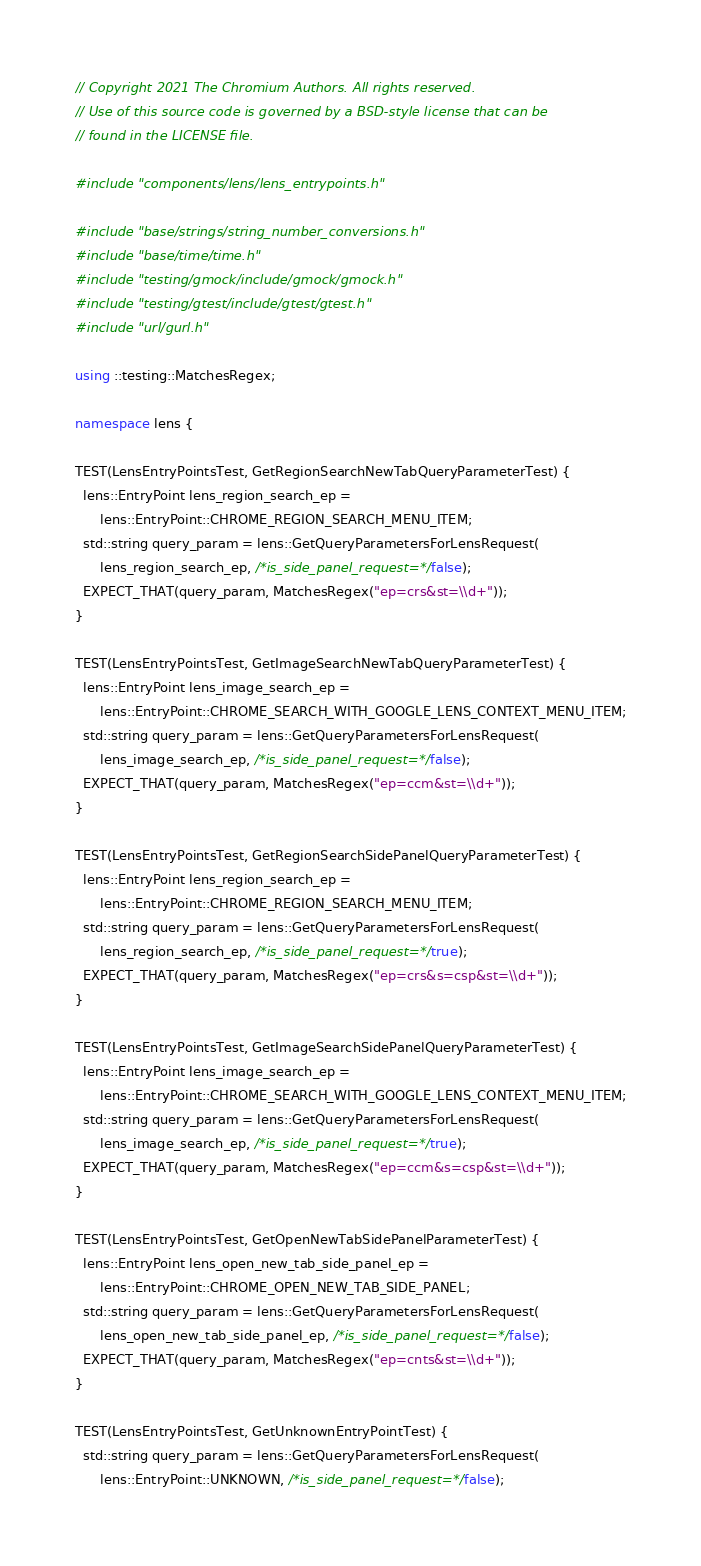Convert code to text. <code><loc_0><loc_0><loc_500><loc_500><_C++_>// Copyright 2021 The Chromium Authors. All rights reserved.
// Use of this source code is governed by a BSD-style license that can be
// found in the LICENSE file.

#include "components/lens/lens_entrypoints.h"

#include "base/strings/string_number_conversions.h"
#include "base/time/time.h"
#include "testing/gmock/include/gmock/gmock.h"
#include "testing/gtest/include/gtest/gtest.h"
#include "url/gurl.h"

using ::testing::MatchesRegex;

namespace lens {

TEST(LensEntryPointsTest, GetRegionSearchNewTabQueryParameterTest) {
  lens::EntryPoint lens_region_search_ep =
      lens::EntryPoint::CHROME_REGION_SEARCH_MENU_ITEM;
  std::string query_param = lens::GetQueryParametersForLensRequest(
      lens_region_search_ep, /*is_side_panel_request=*/false);
  EXPECT_THAT(query_param, MatchesRegex("ep=crs&st=\\d+"));
}

TEST(LensEntryPointsTest, GetImageSearchNewTabQueryParameterTest) {
  lens::EntryPoint lens_image_search_ep =
      lens::EntryPoint::CHROME_SEARCH_WITH_GOOGLE_LENS_CONTEXT_MENU_ITEM;
  std::string query_param = lens::GetQueryParametersForLensRequest(
      lens_image_search_ep, /*is_side_panel_request=*/false);
  EXPECT_THAT(query_param, MatchesRegex("ep=ccm&st=\\d+"));
}

TEST(LensEntryPointsTest, GetRegionSearchSidePanelQueryParameterTest) {
  lens::EntryPoint lens_region_search_ep =
      lens::EntryPoint::CHROME_REGION_SEARCH_MENU_ITEM;
  std::string query_param = lens::GetQueryParametersForLensRequest(
      lens_region_search_ep, /*is_side_panel_request=*/true);
  EXPECT_THAT(query_param, MatchesRegex("ep=crs&s=csp&st=\\d+"));
}

TEST(LensEntryPointsTest, GetImageSearchSidePanelQueryParameterTest) {
  lens::EntryPoint lens_image_search_ep =
      lens::EntryPoint::CHROME_SEARCH_WITH_GOOGLE_LENS_CONTEXT_MENU_ITEM;
  std::string query_param = lens::GetQueryParametersForLensRequest(
      lens_image_search_ep, /*is_side_panel_request=*/true);
  EXPECT_THAT(query_param, MatchesRegex("ep=ccm&s=csp&st=\\d+"));
}

TEST(LensEntryPointsTest, GetOpenNewTabSidePanelParameterTest) {
  lens::EntryPoint lens_open_new_tab_side_panel_ep =
      lens::EntryPoint::CHROME_OPEN_NEW_TAB_SIDE_PANEL;
  std::string query_param = lens::GetQueryParametersForLensRequest(
      lens_open_new_tab_side_panel_ep, /*is_side_panel_request=*/false);
  EXPECT_THAT(query_param, MatchesRegex("ep=cnts&st=\\d+"));
}

TEST(LensEntryPointsTest, GetUnknownEntryPointTest) {
  std::string query_param = lens::GetQueryParametersForLensRequest(
      lens::EntryPoint::UNKNOWN, /*is_side_panel_request=*/false);</code> 